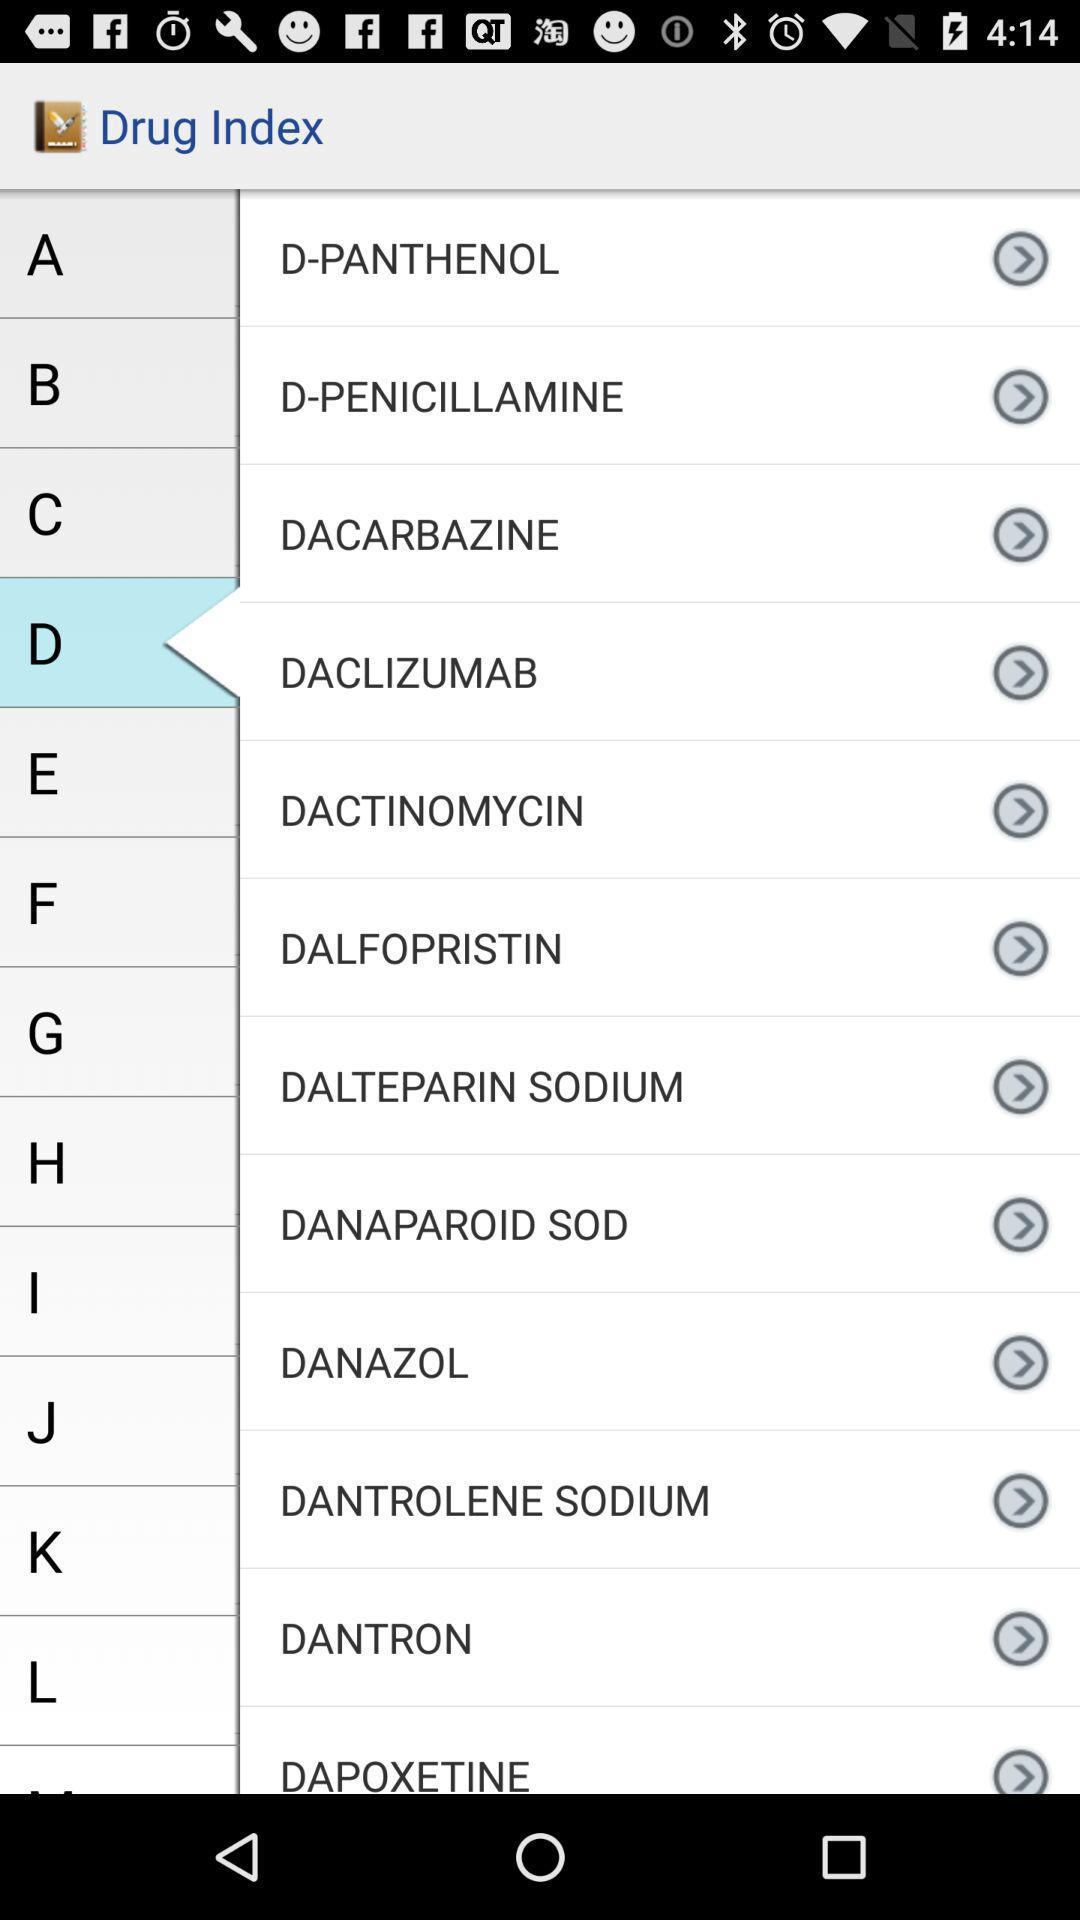What drug index is selected? The selected drug index is "D". 